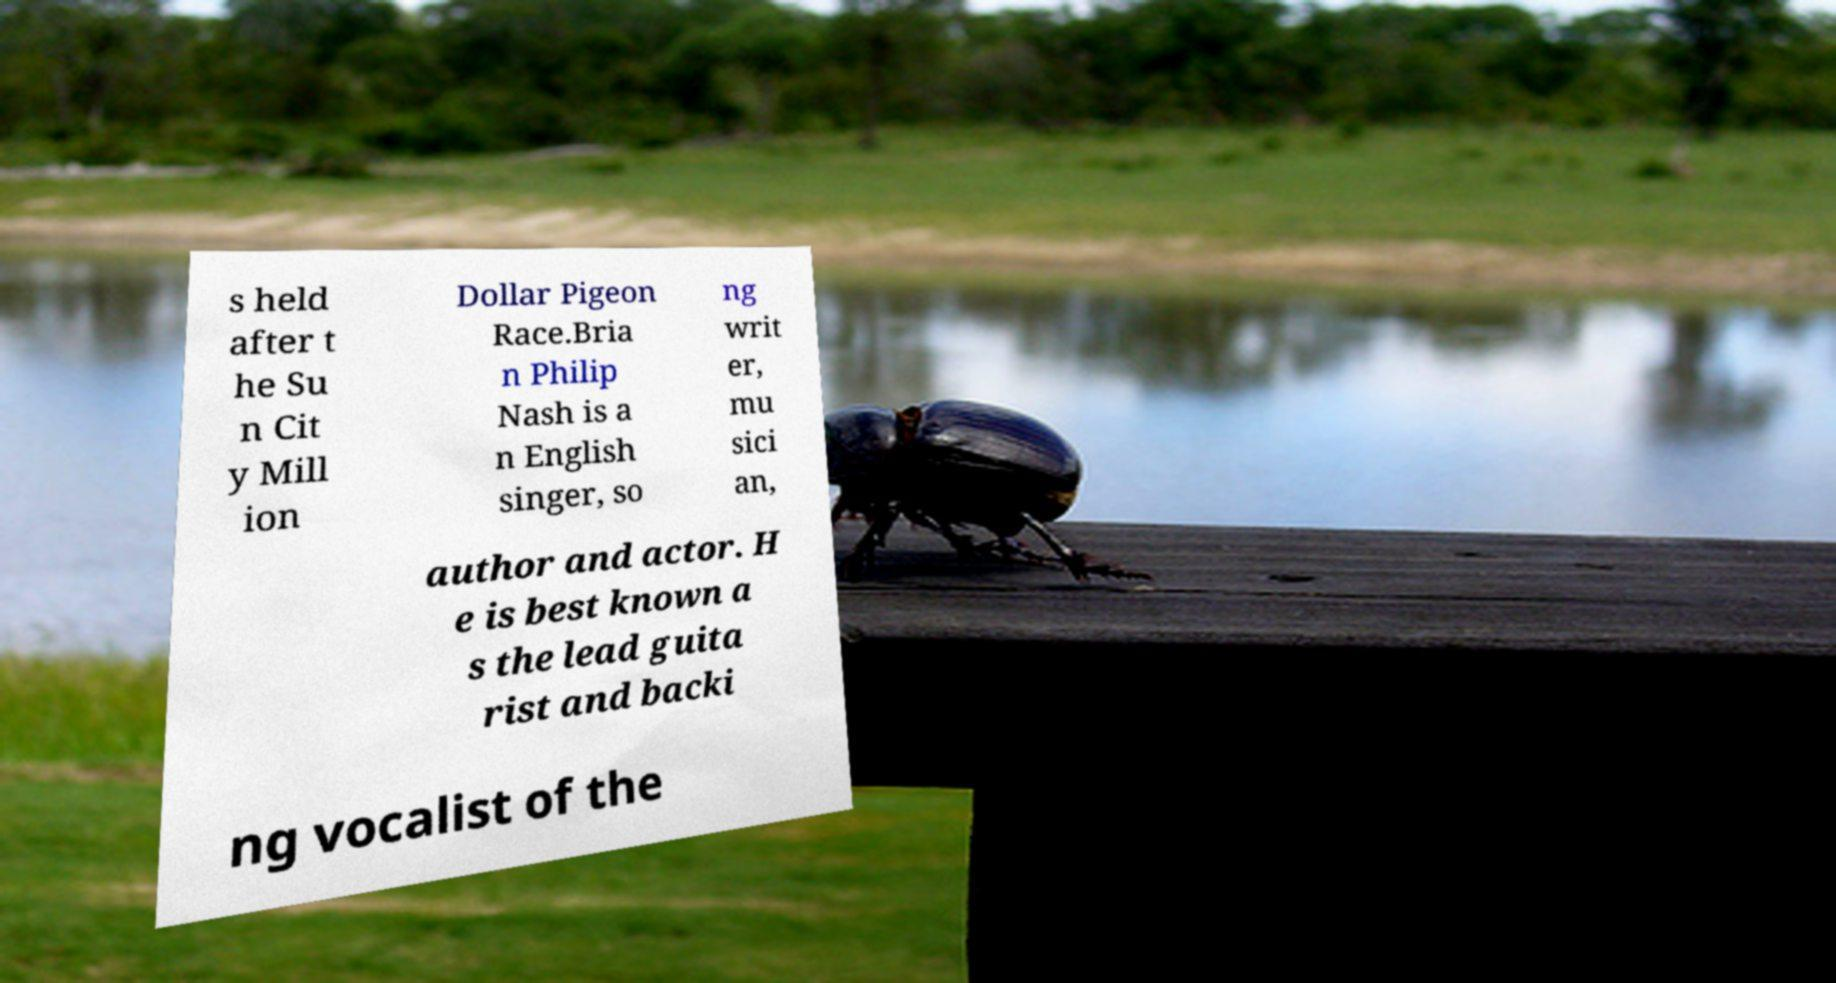What messages or text are displayed in this image? I need them in a readable, typed format. s held after t he Su n Cit y Mill ion Dollar Pigeon Race.Bria n Philip Nash is a n English singer, so ng writ er, mu sici an, author and actor. H e is best known a s the lead guita rist and backi ng vocalist of the 